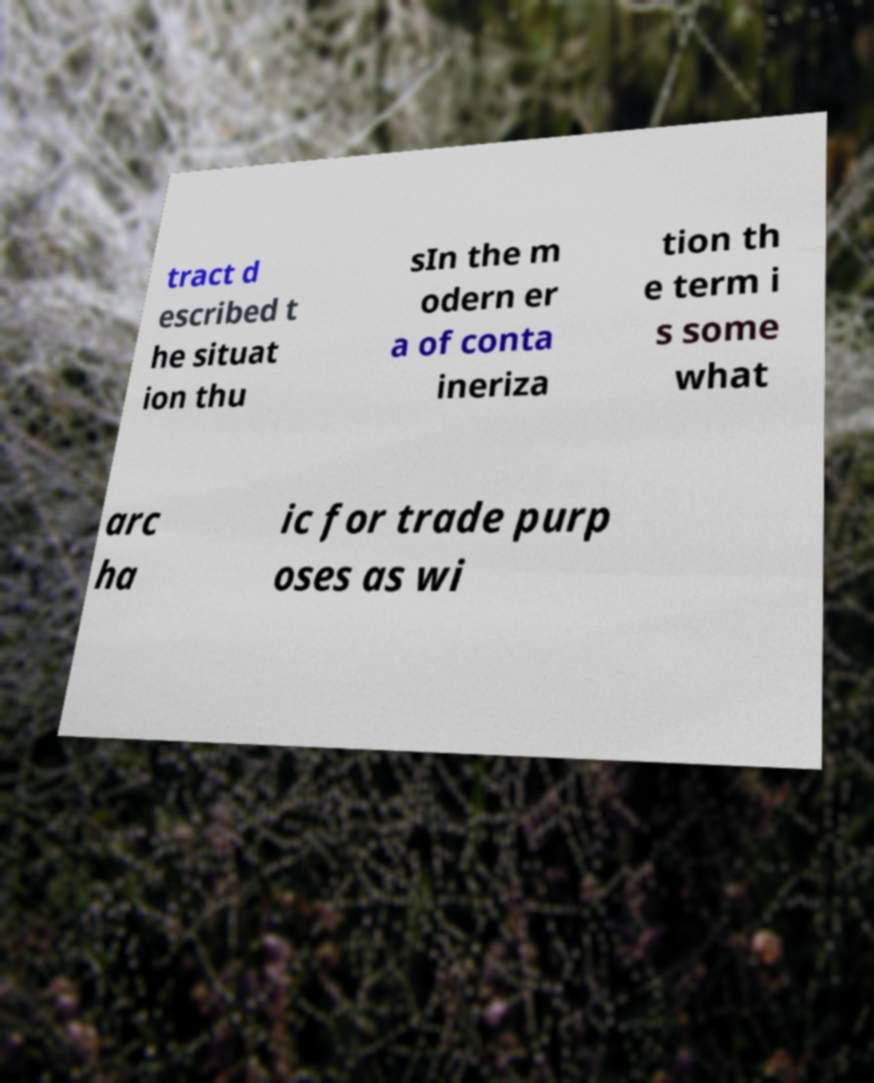Could you extract and type out the text from this image? tract d escribed t he situat ion thu sIn the m odern er a of conta ineriza tion th e term i s some what arc ha ic for trade purp oses as wi 